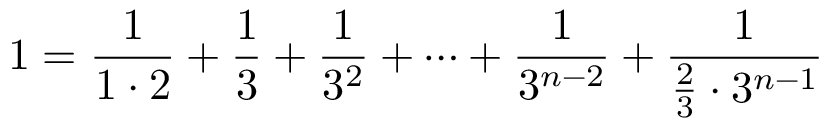Convert formula to latex. <formula><loc_0><loc_0><loc_500><loc_500>1 = { \frac { 1 } { 1 \cdot 2 } } + { \frac { 1 } { 3 } } + { \frac { 1 } { 3 ^ { 2 } } } + \dots + { \frac { 1 } { 3 ^ { n - 2 } } } + { \frac { 1 } { { \frac { 2 } { 3 } } \cdot 3 ^ { n - 1 } } }</formula> 